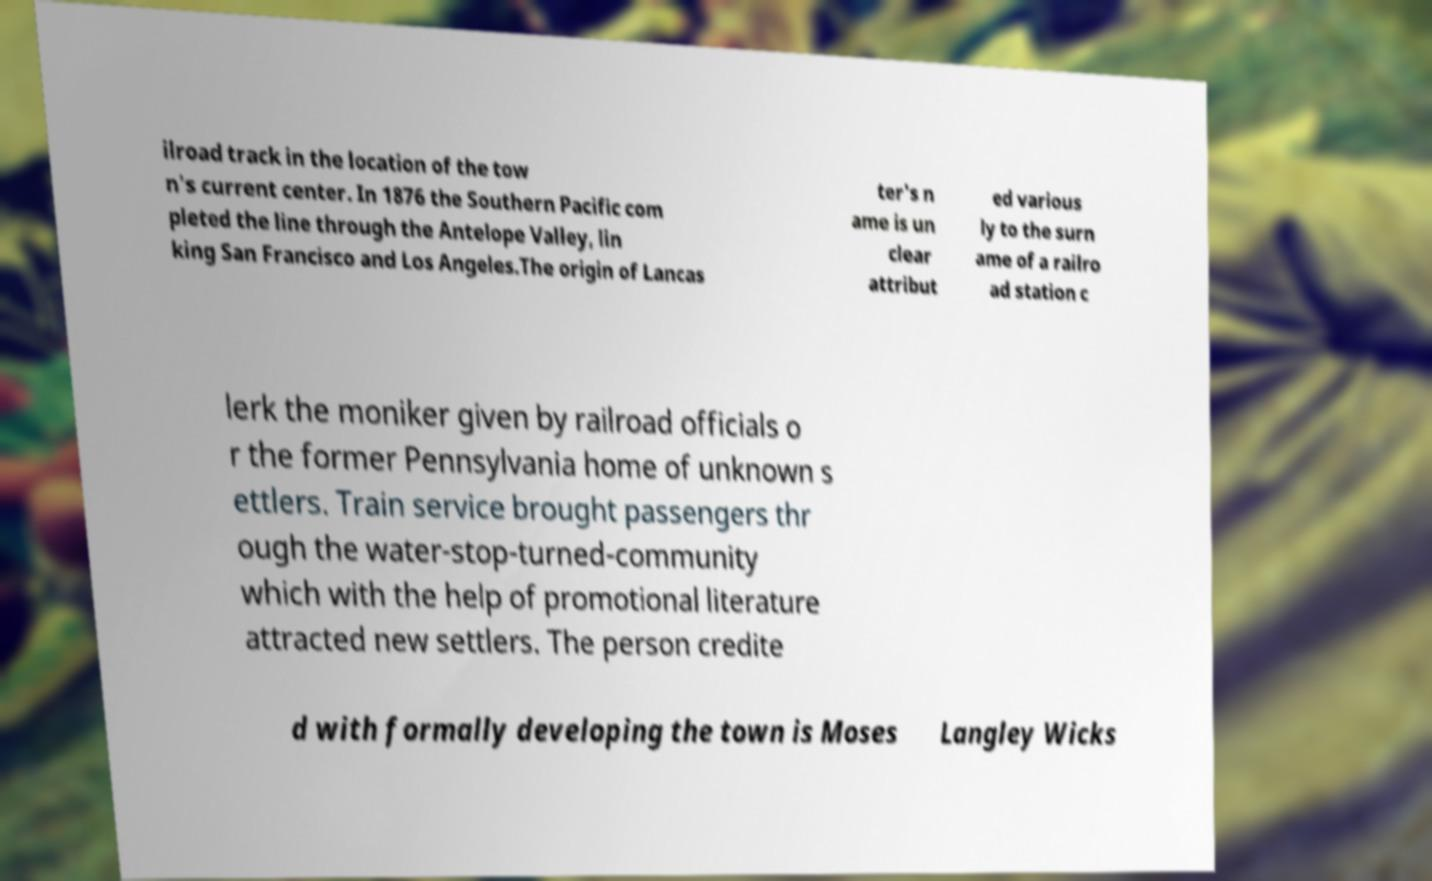What messages or text are displayed in this image? I need them in a readable, typed format. ilroad track in the location of the tow n's current center. In 1876 the Southern Pacific com pleted the line through the Antelope Valley, lin king San Francisco and Los Angeles.The origin of Lancas ter's n ame is un clear attribut ed various ly to the surn ame of a railro ad station c lerk the moniker given by railroad officials o r the former Pennsylvania home of unknown s ettlers. Train service brought passengers thr ough the water-stop-turned-community which with the help of promotional literature attracted new settlers. The person credite d with formally developing the town is Moses Langley Wicks 